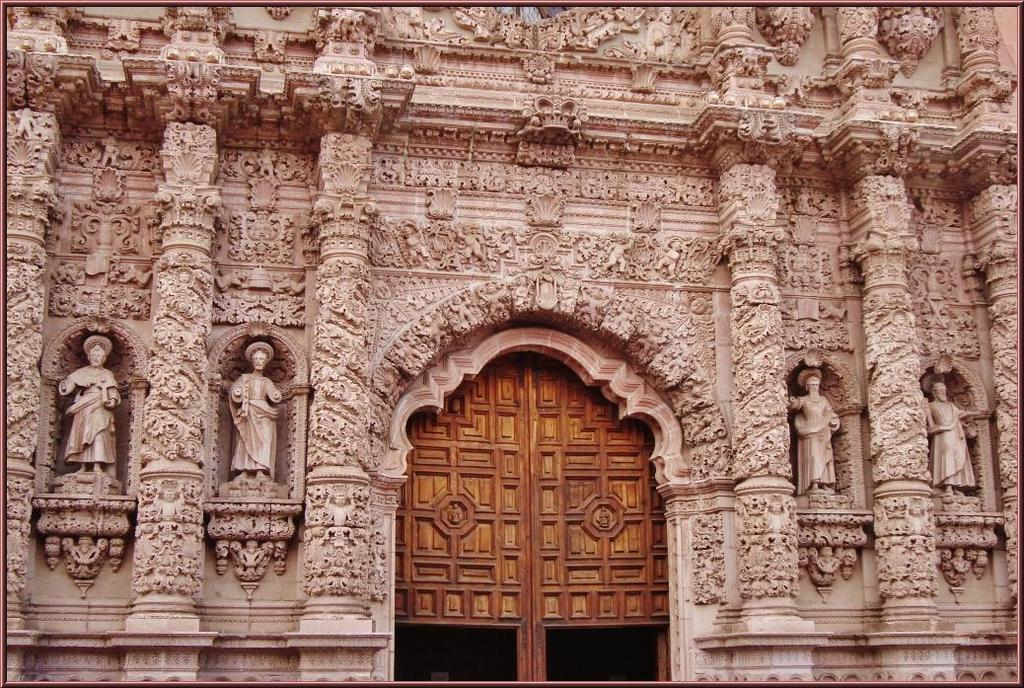What type of structure is visible in the image? There is a building in the image. What distinguishes the building from other structures? The building has many carvings. Where is the entrance to the building located? There is a door in the middle of the building. Can you see a lake in the background of the image? There is no lake visible in the image; it features a building with carvings and a door. What type of frog can be seen sitting on the carvings of the building? There are no frogs present in the image; it only shows a building with carvings and a door. 